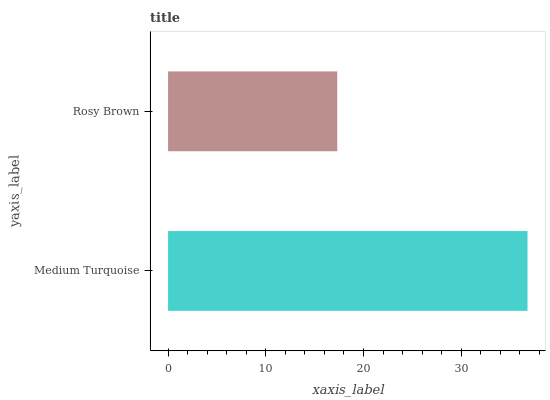Is Rosy Brown the minimum?
Answer yes or no. Yes. Is Medium Turquoise the maximum?
Answer yes or no. Yes. Is Rosy Brown the maximum?
Answer yes or no. No. Is Medium Turquoise greater than Rosy Brown?
Answer yes or no. Yes. Is Rosy Brown less than Medium Turquoise?
Answer yes or no. Yes. Is Rosy Brown greater than Medium Turquoise?
Answer yes or no. No. Is Medium Turquoise less than Rosy Brown?
Answer yes or no. No. Is Medium Turquoise the high median?
Answer yes or no. Yes. Is Rosy Brown the low median?
Answer yes or no. Yes. Is Rosy Brown the high median?
Answer yes or no. No. Is Medium Turquoise the low median?
Answer yes or no. No. 